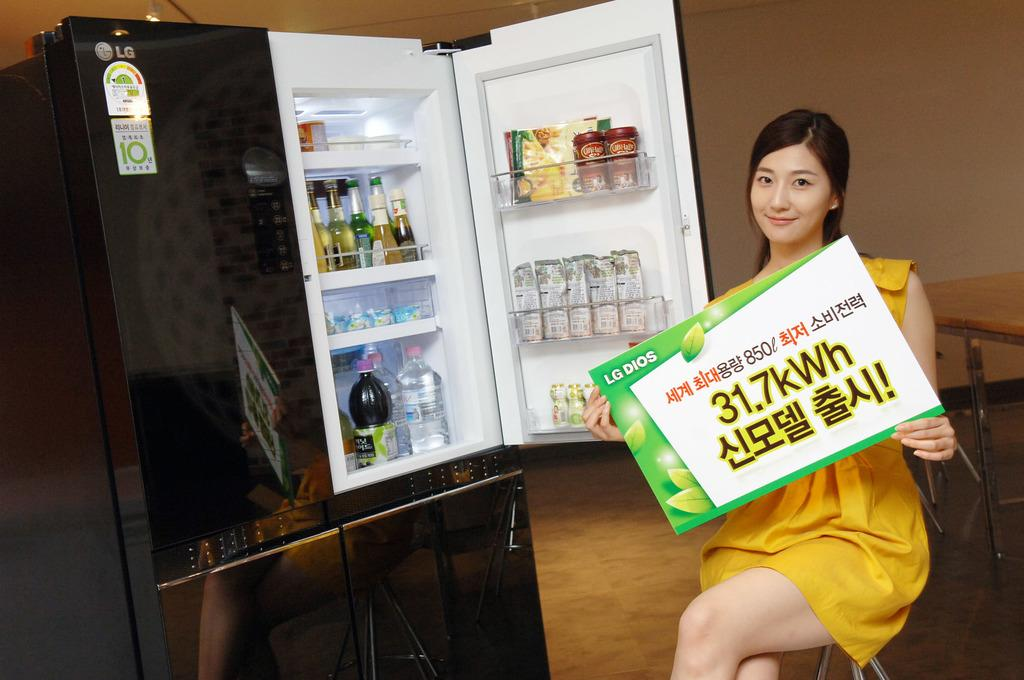<image>
Present a compact description of the photo's key features. a woman sitting in front of a mini fridge with sign reading 31.7 kWh 